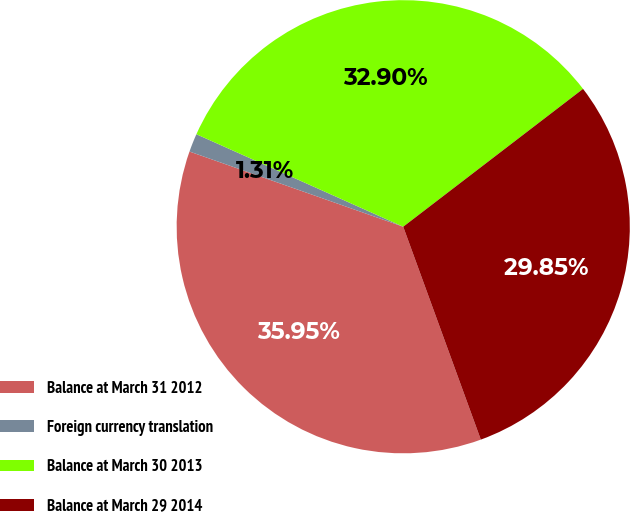<chart> <loc_0><loc_0><loc_500><loc_500><pie_chart><fcel>Balance at March 31 2012<fcel>Foreign currency translation<fcel>Balance at March 30 2013<fcel>Balance at March 29 2014<nl><fcel>35.95%<fcel>1.31%<fcel>32.9%<fcel>29.85%<nl></chart> 